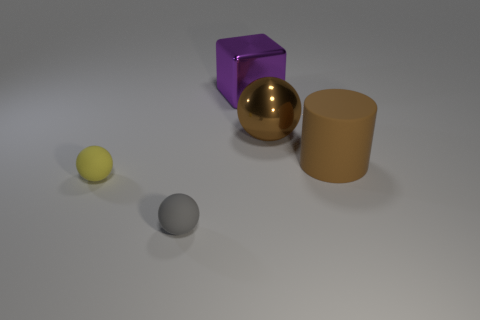Subtract all small gray spheres. How many spheres are left? 2 Add 3 shiny cubes. How many objects exist? 8 Subtract all cylinders. How many objects are left? 4 Subtract 0 red blocks. How many objects are left? 5 Subtract all metallic things. Subtract all green cubes. How many objects are left? 3 Add 1 purple metallic objects. How many purple metallic objects are left? 2 Add 1 brown matte spheres. How many brown matte spheres exist? 1 